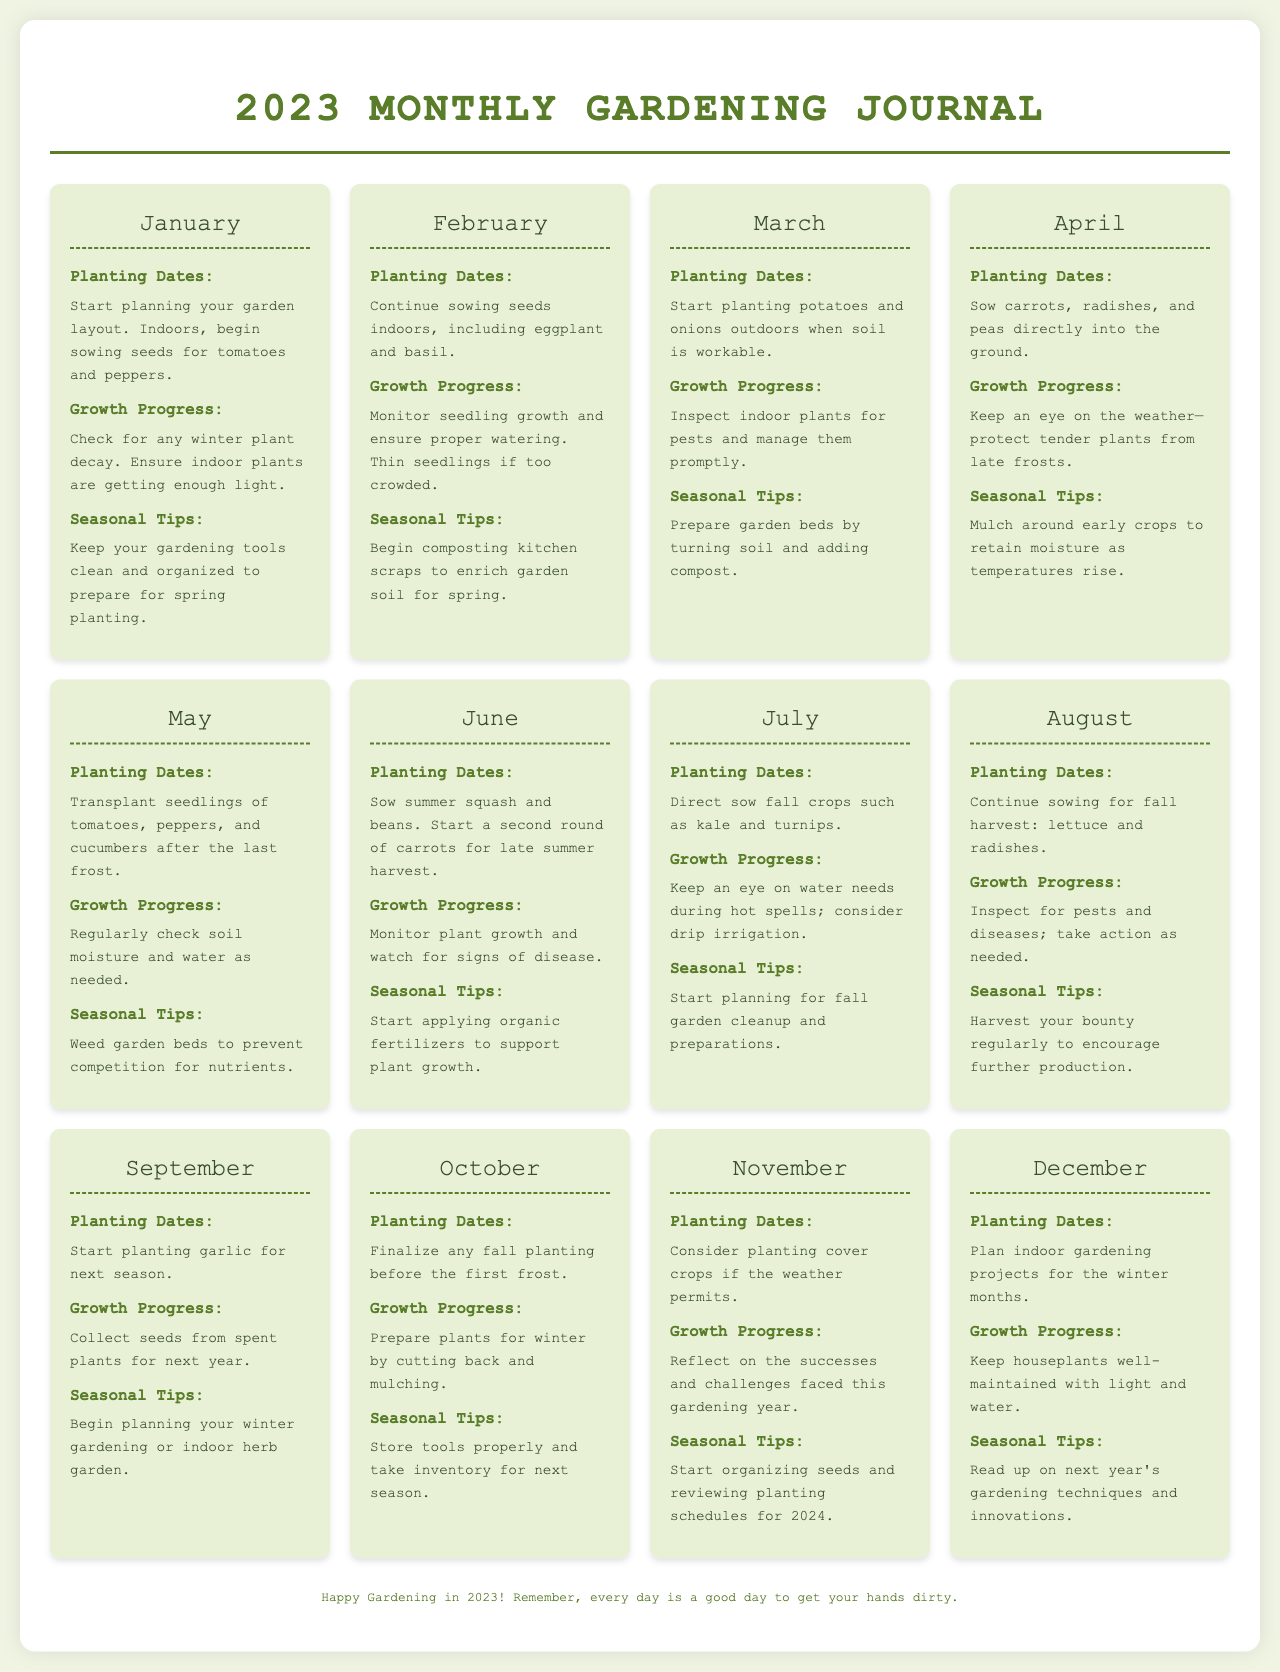what should you start planting in January? January suggests starting to sow seeds for tomatoes and peppers indoors.
Answer: tomatoes and peppers which vegetables can be directly sown in April? April advises sowing carrots, radishes, and peas directly into the ground.
Answer: carrots, radishes, and peas what is a seasonal tip for June? June recommends starting to apply organic fertilizers to support plant growth.
Answer: apply organic fertilizers when should you monitor seedling growth? February is the month to monitor seedling growth and ensure proper watering.
Answer: February how do you prepare plants for winter in October? October suggests preparing plants by cutting back and mulching.
Answer: cutting back and mulching what planting is recommended for September? September indicates starting to plant garlic for the next season.
Answer: garlic how many sections are in each month’s gardening journal? Each month consists of three sections: Planting Dates, Growth Progress, and Seasonal Tips.
Answer: three which month involves reflecting on gardening successes? November includes reflecting on the successes and challenges faced this gardening year.
Answer: November what should you do in December regarding indoor gardening? December recommends planning indoor gardening projects for the winter months.
Answer: plan indoor gardening projects 